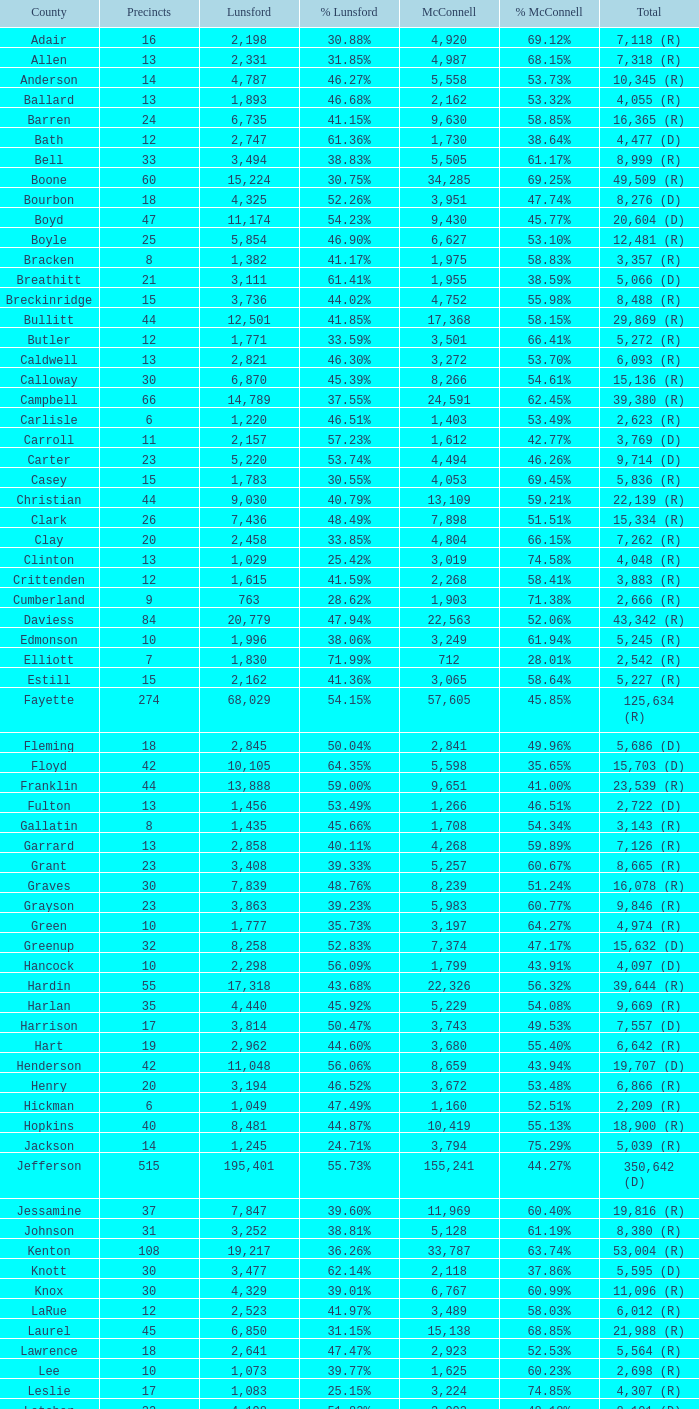85%? 1.0. 